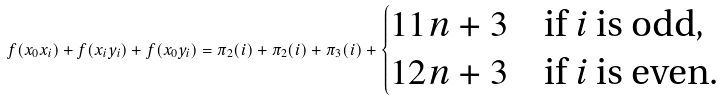Convert formula to latex. <formula><loc_0><loc_0><loc_500><loc_500>f ( x _ { 0 } x _ { i } ) + f ( x _ { i } y _ { i } ) + f ( x _ { 0 } y _ { i } ) = \pi _ { 2 } ( i ) + \pi _ { 2 } ( i ) + \pi _ { 3 } ( i ) + \begin{cases} 1 1 n + 3 & \text {if $i$ is odd} , \\ 1 2 n + 3 & \text {if $i$ is even} . \end{cases}</formula> 